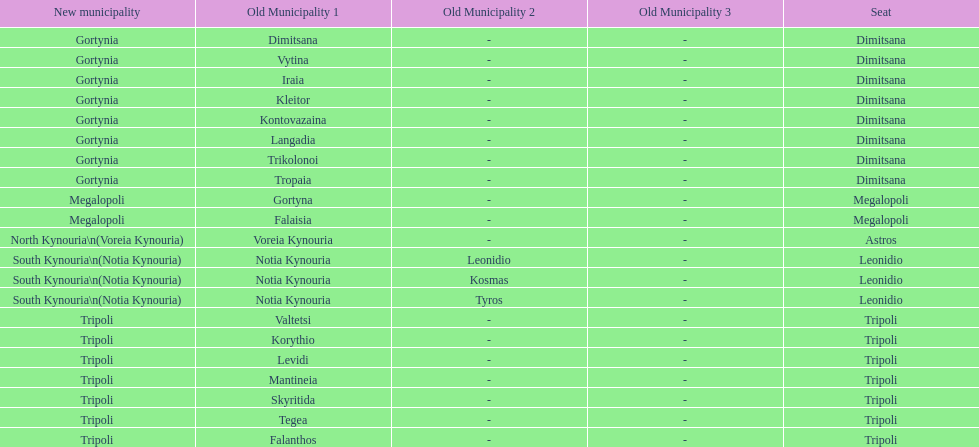How many old municipalities were in tripoli? 8. 